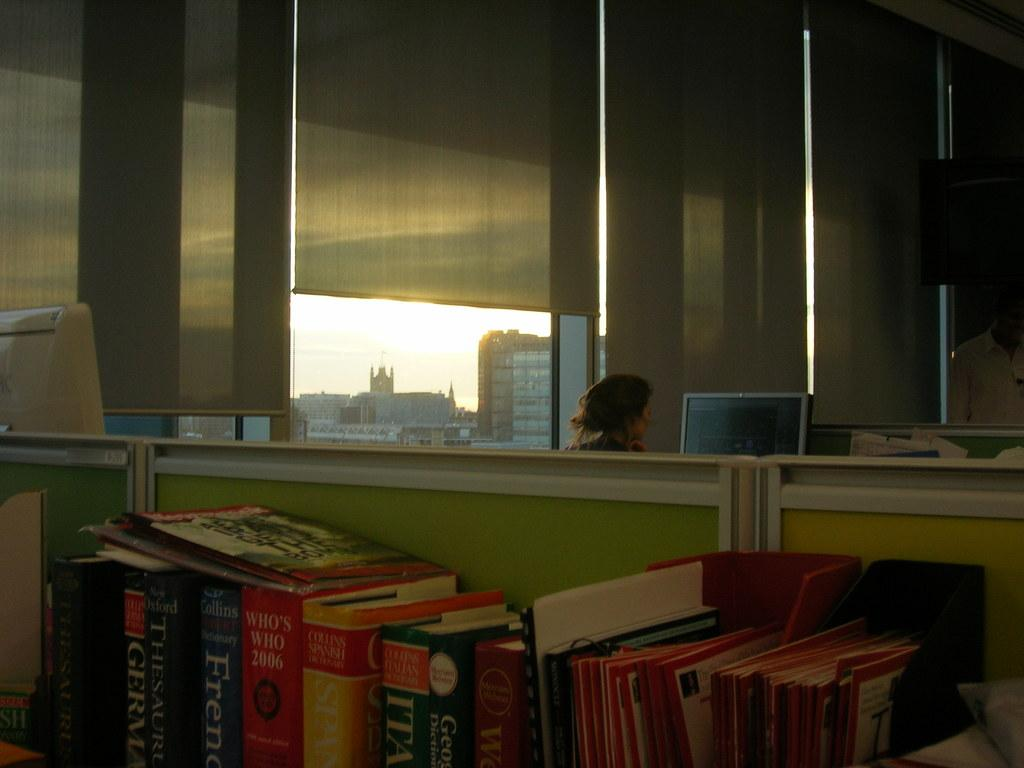<image>
Relay a brief, clear account of the picture shown. A bunch of books on a table, one called Who's Who 2006 